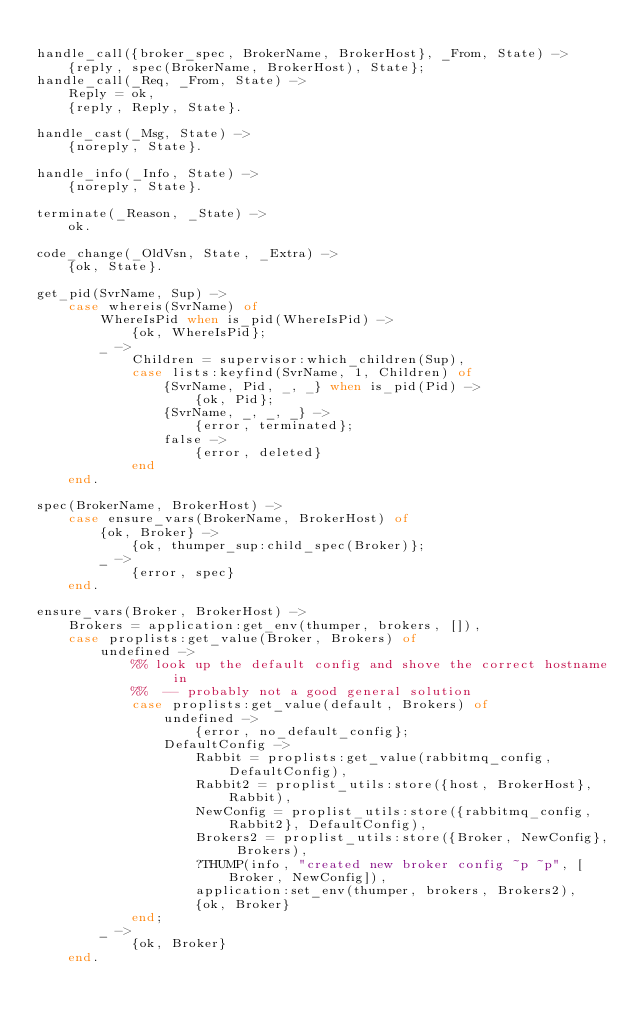<code> <loc_0><loc_0><loc_500><loc_500><_Erlang_>
handle_call({broker_spec, BrokerName, BrokerHost}, _From, State) ->
    {reply, spec(BrokerName, BrokerHost), State};
handle_call(_Req, _From, State) ->
    Reply = ok,
    {reply, Reply, State}.

handle_cast(_Msg, State) ->
    {noreply, State}.

handle_info(_Info, State) ->
    {noreply, State}.

terminate(_Reason, _State) ->
    ok.

code_change(_OldVsn, State, _Extra) ->
    {ok, State}.

get_pid(SvrName, Sup) ->
    case whereis(SvrName) of
        WhereIsPid when is_pid(WhereIsPid) ->
            {ok, WhereIsPid};
        _ ->
            Children = supervisor:which_children(Sup),
            case lists:keyfind(SvrName, 1, Children) of
                {SvrName, Pid, _, _} when is_pid(Pid) ->
                    {ok, Pid};
                {SvrName, _, _, _} ->
                    {error, terminated};
                false ->
                    {error, deleted}
            end
    end.

spec(BrokerName, BrokerHost) ->
    case ensure_vars(BrokerName, BrokerHost) of
        {ok, Broker} ->
            {ok, thumper_sup:child_spec(Broker)};
        _ ->
            {error, spec}
    end.

ensure_vars(Broker, BrokerHost) ->
    Brokers = application:get_env(thumper, brokers, []),
    case proplists:get_value(Broker, Brokers) of
        undefined ->
            %% look up the default config and shove the correct hostname in
            %%  -- probably not a good general solution
            case proplists:get_value(default, Brokers) of
                undefined ->
                    {error, no_default_config};
                DefaultConfig ->
                    Rabbit = proplists:get_value(rabbitmq_config, DefaultConfig),
                    Rabbit2 = proplist_utils:store({host, BrokerHost}, Rabbit),
                    NewConfig = proplist_utils:store({rabbitmq_config, Rabbit2}, DefaultConfig),
                    Brokers2 = proplist_utils:store({Broker, NewConfig}, Brokers),
                    ?THUMP(info, "created new broker config ~p ~p", [Broker, NewConfig]),
                    application:set_env(thumper, brokers, Brokers2),
                    {ok, Broker}
            end;
        _ ->
            {ok, Broker}
    end.
</code> 